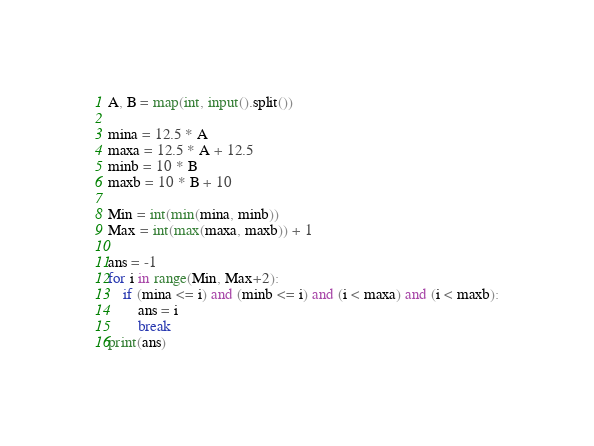Convert code to text. <code><loc_0><loc_0><loc_500><loc_500><_Python_>A, B = map(int, input().split())

mina = 12.5 * A 
maxa = 12.5 * A + 12.5
minb = 10 * B 
maxb = 10 * B + 10

Min = int(min(mina, minb))
Max = int(max(maxa, maxb)) + 1

ans = -1
for i in range(Min, Max+2):
    if (mina <= i) and (minb <= i) and (i < maxa) and (i < maxb):
        ans = i
        break
print(ans)</code> 